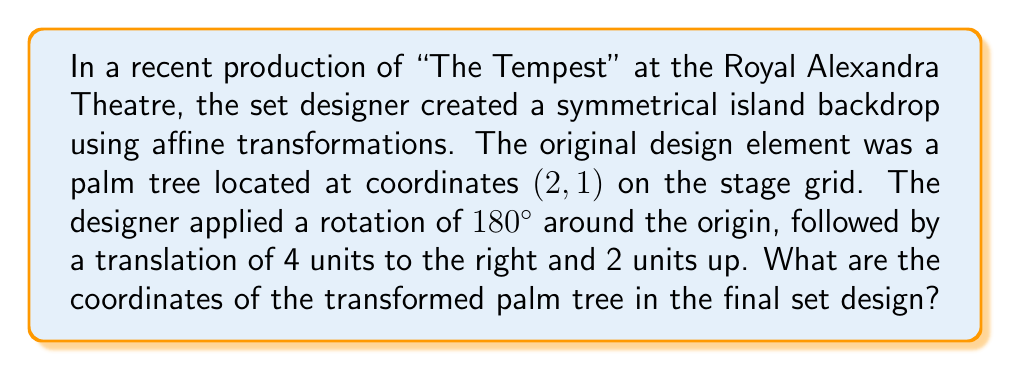Could you help me with this problem? Let's approach this step-by-step using affine transformations:

1) First, we need to apply the rotation of 180° around the origin. The rotation matrix for 180° is:
   $$R = \begin{pmatrix} -1 & 0 \\ 0 & -1 \end{pmatrix}$$

2) Apply this rotation to the original coordinates (2, 1):
   $$\begin{pmatrix} -1 & 0 \\ 0 & -1 \end{pmatrix} \begin{pmatrix} 2 \\ 1 \end{pmatrix} = \begin{pmatrix} -2 \\ -1 \end{pmatrix}$$

3) After rotation, the coordinates are (-2, -1).

4) Next, we apply the translation of 4 units right and 2 units up. In vector notation, this is:
   $$\begin{pmatrix} 4 \\ 2 \end{pmatrix}$$

5) To apply the translation, we add this vector to our rotated coordinates:
   $$\begin{pmatrix} -2 \\ -1 \end{pmatrix} + \begin{pmatrix} 4 \\ 2 \end{pmatrix} = \begin{pmatrix} 2 \\ 1 \end{pmatrix}$$

Therefore, the final coordinates of the transformed palm tree are (2, 1).
Answer: (2, 1) 